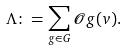Convert formula to latex. <formula><loc_0><loc_0><loc_500><loc_500>\Lambda \colon = \sum _ { g \in G } { \mathcal { O } } g ( v ) .</formula> 